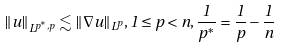<formula> <loc_0><loc_0><loc_500><loc_500>\| u \| _ { L ^ { p ^ { * } , p } } \lesssim \| \nabla u \| _ { L ^ { p } } , 1 \leq p < n , \frac { 1 } { p ^ { * } } = \frac { 1 } { p } - \frac { 1 } { n }</formula> 